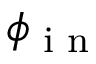Convert formula to latex. <formula><loc_0><loc_0><loc_500><loc_500>\phi _ { i n }</formula> 